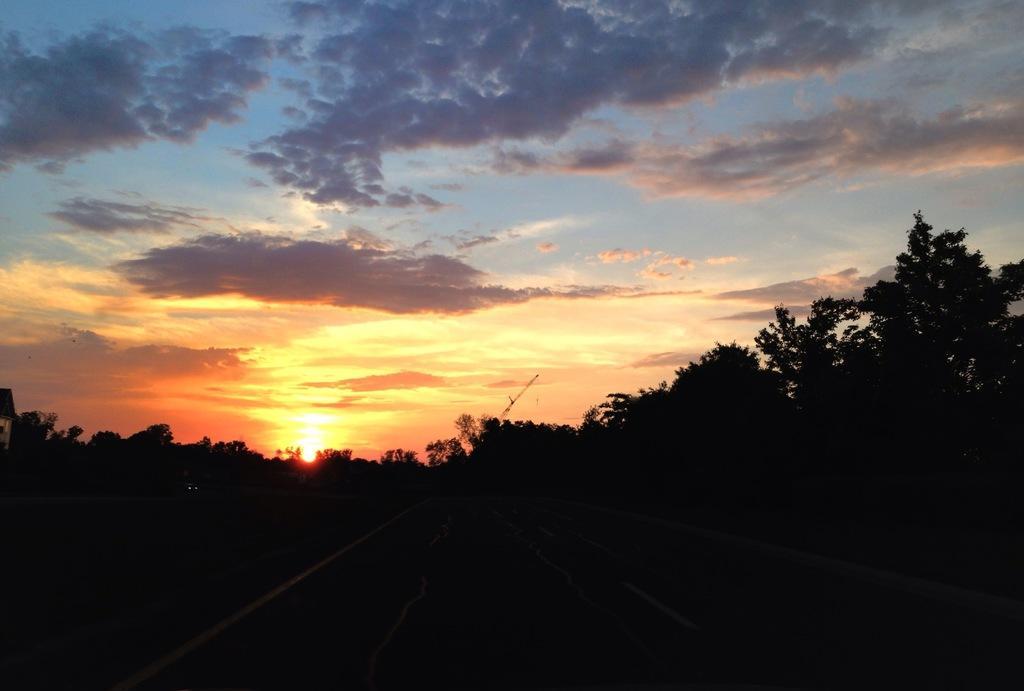In one or two sentences, can you explain what this image depicts? In this image I can see few trees, background the sky is in blue, white and orange color. 